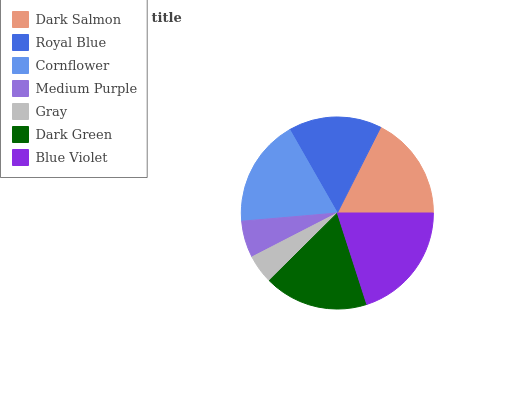Is Gray the minimum?
Answer yes or no. Yes. Is Blue Violet the maximum?
Answer yes or no. Yes. Is Royal Blue the minimum?
Answer yes or no. No. Is Royal Blue the maximum?
Answer yes or no. No. Is Dark Salmon greater than Royal Blue?
Answer yes or no. Yes. Is Royal Blue less than Dark Salmon?
Answer yes or no. Yes. Is Royal Blue greater than Dark Salmon?
Answer yes or no. No. Is Dark Salmon less than Royal Blue?
Answer yes or no. No. Is Dark Green the high median?
Answer yes or no. Yes. Is Dark Green the low median?
Answer yes or no. Yes. Is Cornflower the high median?
Answer yes or no. No. Is Dark Salmon the low median?
Answer yes or no. No. 